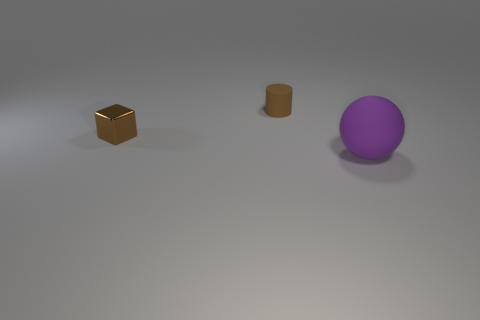Are there any other things that are the same size as the purple rubber sphere?
Your response must be concise. No. Are there any brown cylinders right of the large matte object?
Provide a succinct answer. No. What number of other things are there of the same shape as the big purple thing?
Your answer should be compact. 0. There is a metal cube that is the same size as the brown rubber cylinder; what color is it?
Provide a succinct answer. Brown. Are there fewer tiny metallic objects that are right of the small brown matte object than brown cylinders that are in front of the purple ball?
Ensure brevity in your answer.  No. What number of brown rubber things are in front of the tiny brown object in front of the matte object that is to the left of the big object?
Make the answer very short. 0. Is the number of tiny shiny blocks in front of the purple thing less than the number of tiny brown metal cubes?
Provide a short and direct response. Yes. Is the small metal object the same shape as the brown rubber object?
Your response must be concise. No. What number of tiny things are the same color as the matte cylinder?
Give a very brief answer. 1. How many things are brown objects right of the small metal cube or tiny brown metal cubes?
Give a very brief answer. 2. 